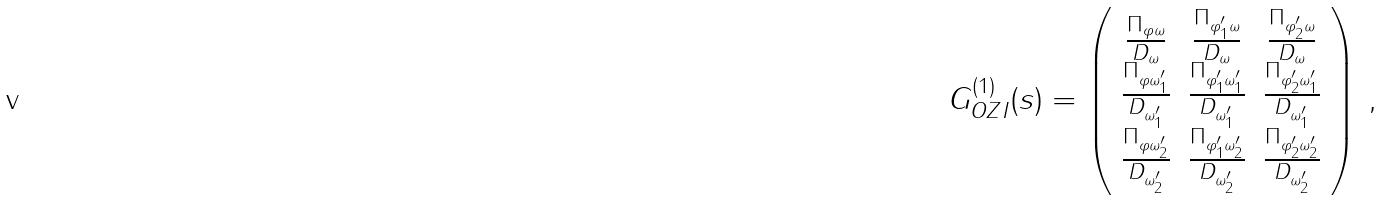Convert formula to latex. <formula><loc_0><loc_0><loc_500><loc_500>G _ { O Z I } ^ { ( 1 ) } ( s ) = \left ( \begin{array} { c c c } { { { \frac { \Pi _ { \varphi \omega } } { D _ { \omega } } } } } & { { { \frac { \Pi _ { \varphi _ { 1 } ^ { \prime } \omega } } { D _ { \omega } } } } } & { { { \frac { \Pi _ { \varphi _ { 2 } ^ { \prime } \omega } } { D _ { \omega } } } } } \\ { { { \frac { \Pi _ { \varphi \omega _ { 1 } ^ { \prime } } } { D _ { \omega _ { 1 } ^ { \prime } } } } } } & { { { \frac { \Pi _ { \varphi _ { 1 } ^ { \prime } \omega _ { 1 } ^ { \prime } } } { D _ { \omega _ { 1 } ^ { \prime } } } } } } & { { { \frac { \Pi _ { \varphi _ { 2 } ^ { \prime } \omega _ { 1 } ^ { \prime } } } { D _ { \omega _ { 1 } ^ { \prime } } } } } } \\ { { { \frac { \Pi _ { \varphi \omega _ { 2 } ^ { \prime } } } { D _ { \omega _ { 2 } ^ { \prime } } } } } } & { { { \frac { \Pi _ { \varphi _ { 1 } ^ { \prime } \omega _ { 2 } ^ { \prime } } } { D _ { \omega _ { 2 } ^ { \prime } } } } } } & { { { \frac { \Pi _ { \varphi _ { 2 } ^ { \prime } \omega _ { 2 } ^ { \prime } } } { D _ { \omega _ { 2 } ^ { \prime } } } } } } \end{array} \right ) \, ,</formula> 